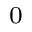<formula> <loc_0><loc_0><loc_500><loc_500>_ { 0 }</formula> 